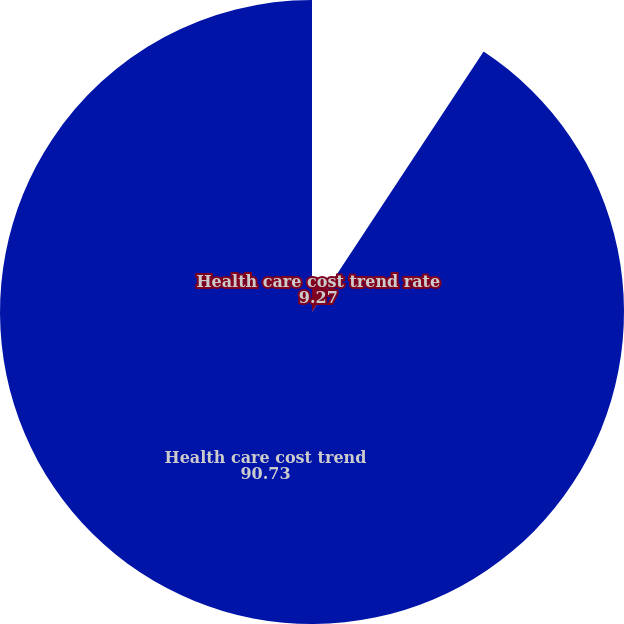Convert chart. <chart><loc_0><loc_0><loc_500><loc_500><pie_chart><fcel>Health care cost trend rate<fcel>Health care cost trend<nl><fcel>9.27%<fcel>90.73%<nl></chart> 